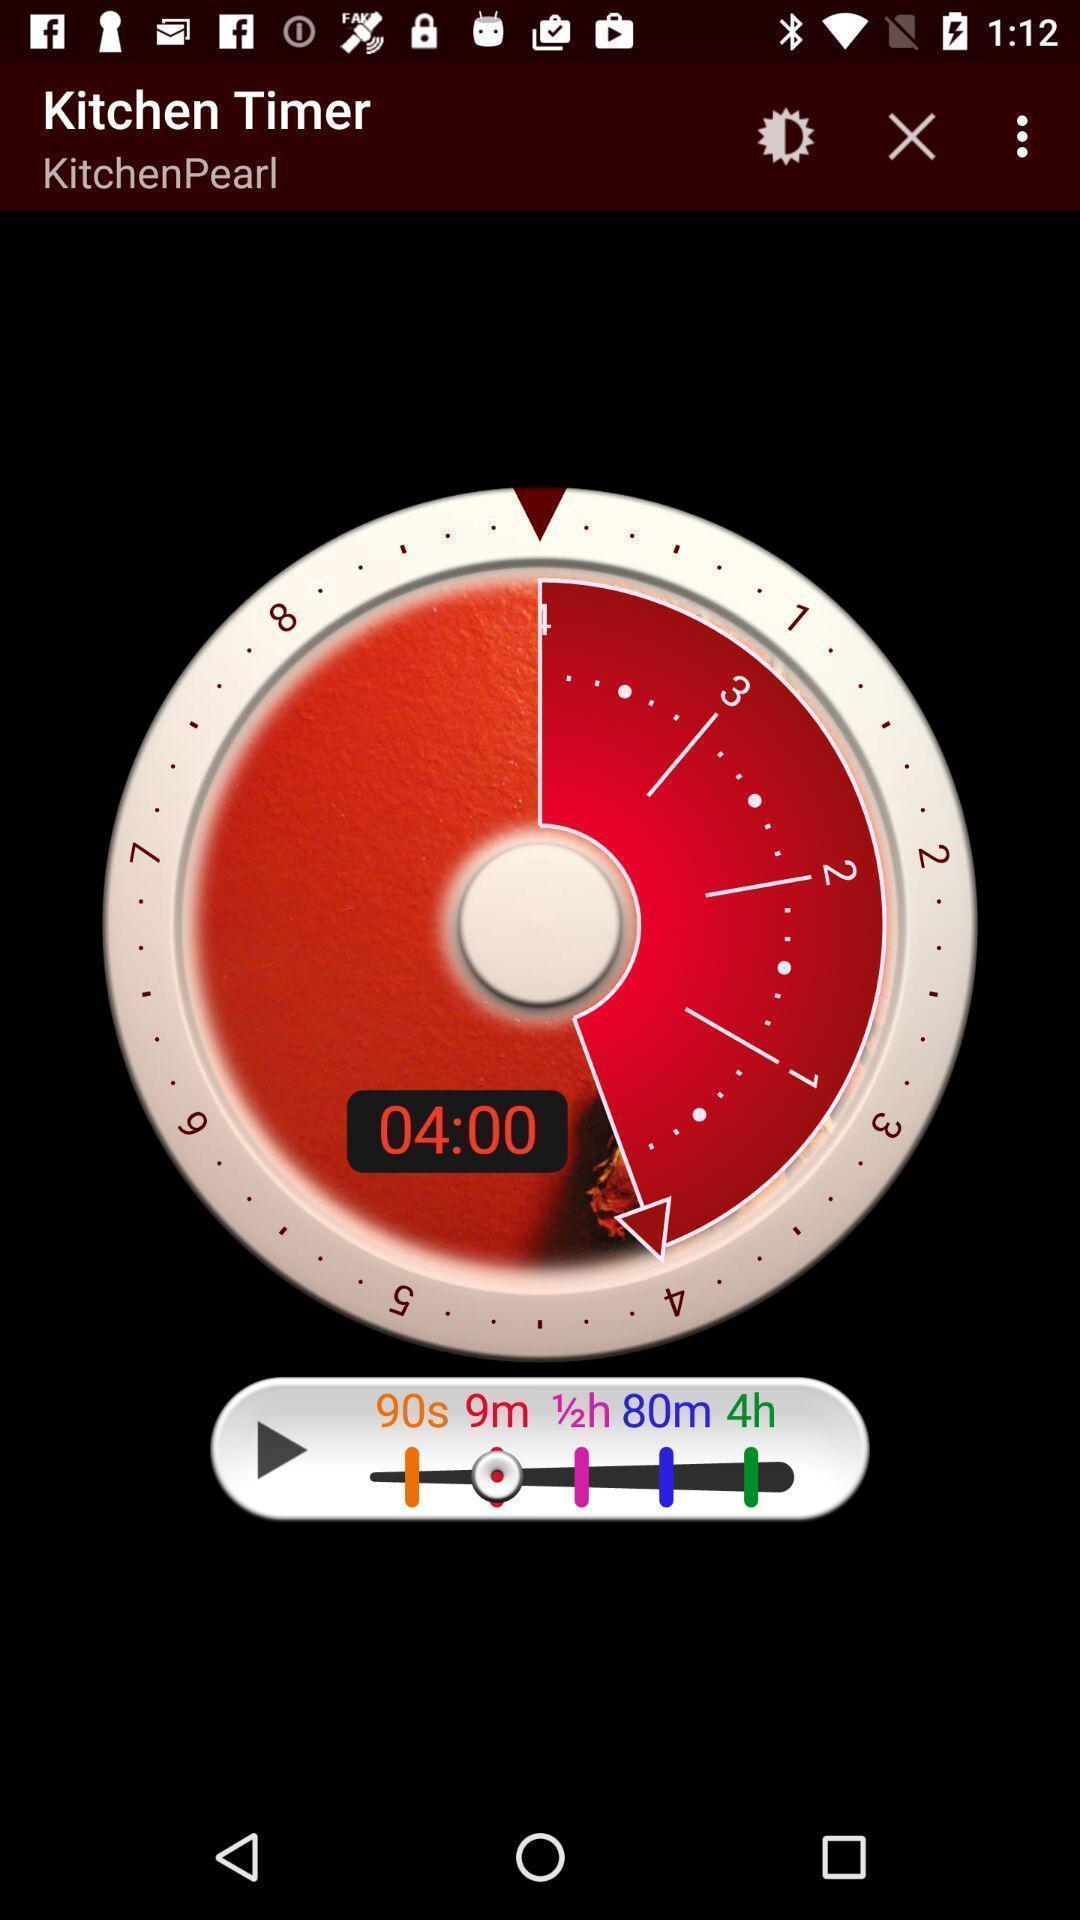Tell me what you see in this picture. Page showing kitchen timer on an app. 